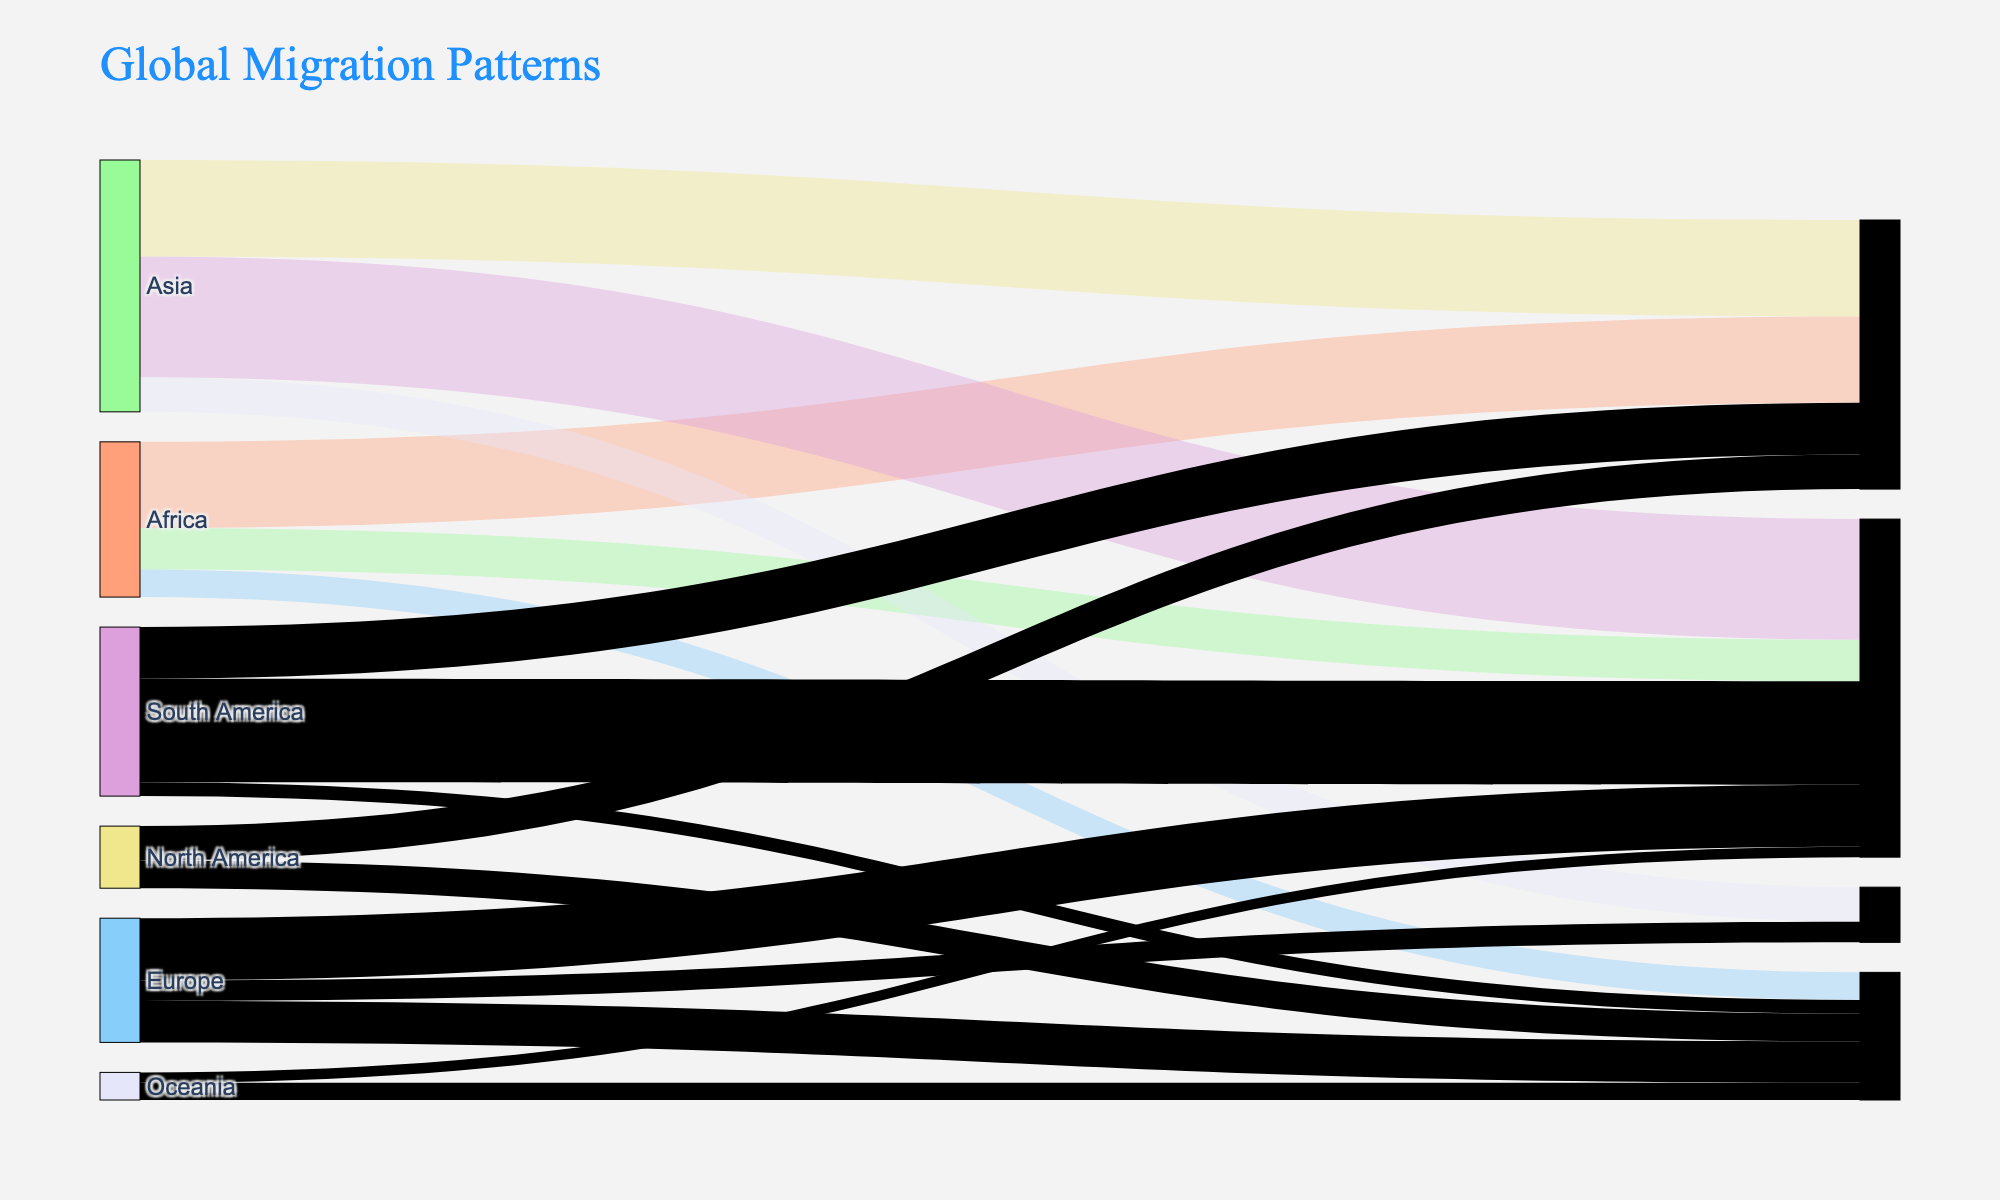What is the title of the figure? The title of the figure is usually displayed prominently at the top. Here, it says "Global Migration Patterns".
Answer: Global Migration Patterns Which continent has the highest migration flow to Europe? To determine this, look at the flows (lines) to Europe and compare their values. The highest flow number to Europe from the data is from Africa with 2,500,000 migrants.
Answer: Africa How much migration flow is there from Asia to North America compared to Europe to North America? For Asia to North America, the value is 3,500,000, and for Europe to North America, it is 1,800,000. Compare these two values. 3,500,000 is greater than 1,800,000.
Answer: Asia to North America has a higher flow What is the total migration flow from Africa? Sum up all the migration values originating from Africa: 2,500,000 (to Europe) + 1,200,000 (to North America) + 800,000 (to Asia) = 4,500,000.
Answer: 4,500,000 Which continent receives the least migration flow from Africa? From the data, Africa sends 2,500,000 to Europe, 1,200,000 to North America, and 800,000 to Asia. The least value here is 800,000 to Asia.
Answer: Asia How much more migration flow is there from South America to North America compared to South America to Europe? The migration flow from South America to North America is 3,000,000, and to Europe is 1,500,000. The difference is 3,000,000 - 1,500,000 = 1,500,000.
Answer: 1,500,000 Which destinations receive migrants from Oceania? Check for all target values where the source is Oceania. The destinations are Asia (500,000) and North America (300,000).
Answer: Asia and North America What is the combined migration flow to North America from all continents? Add up all flows to North America: 1,200,000 (from Africa) + 3,500,000 (from Asia) + 1,800,000 (from Europe) + 3,000,000 (from South America) + 300,000 (from Oceania) = 9,800,000.
Answer: 9,800,000 Which destination receives the highest total migration flow? Sum the flows for each destination and compare. North America: 9,800,000, Europe: 6,000,000, Asia: 6,900,000, Oceania: 1,900,000. The highest total is for North America with 9,800,000.
Answer: North America 